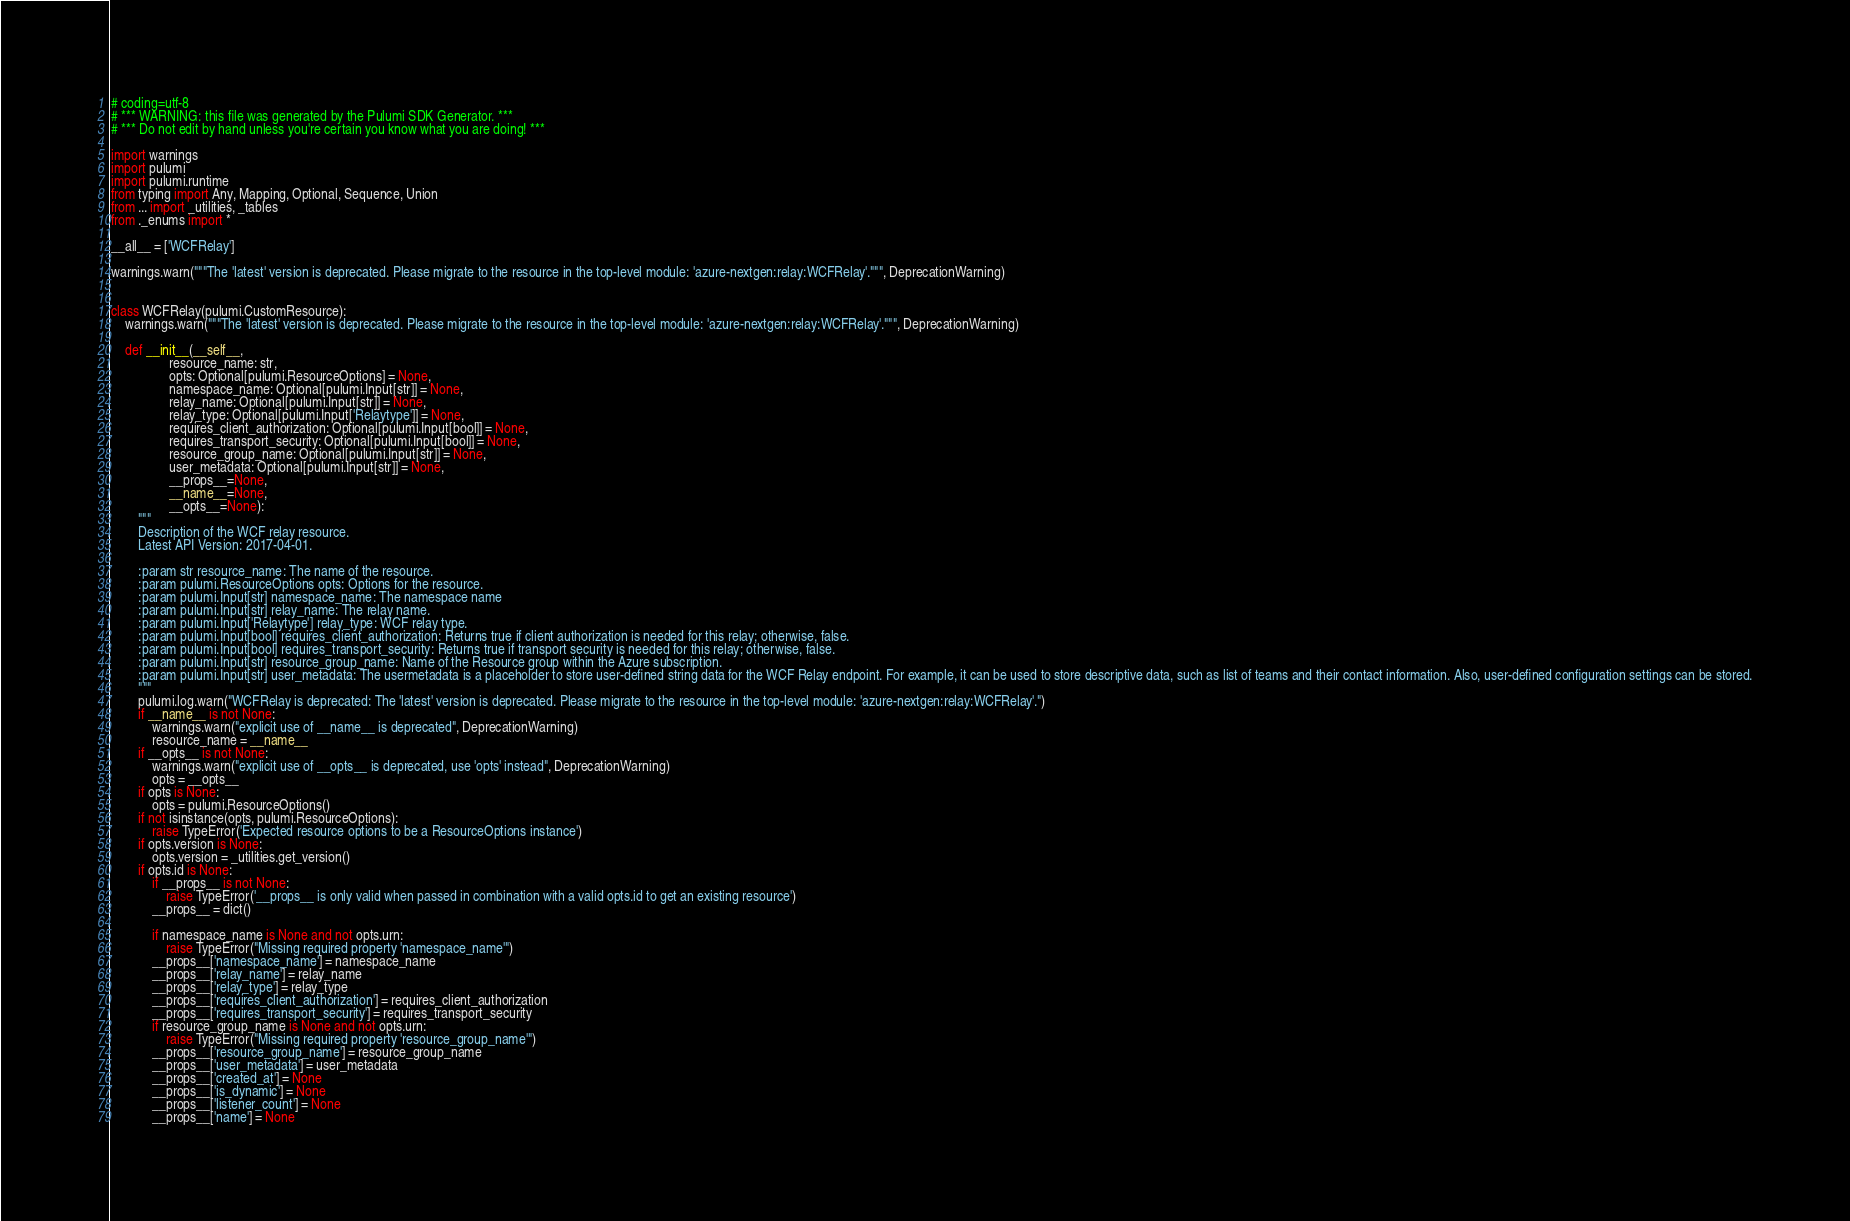Convert code to text. <code><loc_0><loc_0><loc_500><loc_500><_Python_># coding=utf-8
# *** WARNING: this file was generated by the Pulumi SDK Generator. ***
# *** Do not edit by hand unless you're certain you know what you are doing! ***

import warnings
import pulumi
import pulumi.runtime
from typing import Any, Mapping, Optional, Sequence, Union
from ... import _utilities, _tables
from ._enums import *

__all__ = ['WCFRelay']

warnings.warn("""The 'latest' version is deprecated. Please migrate to the resource in the top-level module: 'azure-nextgen:relay:WCFRelay'.""", DeprecationWarning)


class WCFRelay(pulumi.CustomResource):
    warnings.warn("""The 'latest' version is deprecated. Please migrate to the resource in the top-level module: 'azure-nextgen:relay:WCFRelay'.""", DeprecationWarning)

    def __init__(__self__,
                 resource_name: str,
                 opts: Optional[pulumi.ResourceOptions] = None,
                 namespace_name: Optional[pulumi.Input[str]] = None,
                 relay_name: Optional[pulumi.Input[str]] = None,
                 relay_type: Optional[pulumi.Input['Relaytype']] = None,
                 requires_client_authorization: Optional[pulumi.Input[bool]] = None,
                 requires_transport_security: Optional[pulumi.Input[bool]] = None,
                 resource_group_name: Optional[pulumi.Input[str]] = None,
                 user_metadata: Optional[pulumi.Input[str]] = None,
                 __props__=None,
                 __name__=None,
                 __opts__=None):
        """
        Description of the WCF relay resource.
        Latest API Version: 2017-04-01.

        :param str resource_name: The name of the resource.
        :param pulumi.ResourceOptions opts: Options for the resource.
        :param pulumi.Input[str] namespace_name: The namespace name
        :param pulumi.Input[str] relay_name: The relay name.
        :param pulumi.Input['Relaytype'] relay_type: WCF relay type.
        :param pulumi.Input[bool] requires_client_authorization: Returns true if client authorization is needed for this relay; otherwise, false.
        :param pulumi.Input[bool] requires_transport_security: Returns true if transport security is needed for this relay; otherwise, false.
        :param pulumi.Input[str] resource_group_name: Name of the Resource group within the Azure subscription.
        :param pulumi.Input[str] user_metadata: The usermetadata is a placeholder to store user-defined string data for the WCF Relay endpoint. For example, it can be used to store descriptive data, such as list of teams and their contact information. Also, user-defined configuration settings can be stored.
        """
        pulumi.log.warn("WCFRelay is deprecated: The 'latest' version is deprecated. Please migrate to the resource in the top-level module: 'azure-nextgen:relay:WCFRelay'.")
        if __name__ is not None:
            warnings.warn("explicit use of __name__ is deprecated", DeprecationWarning)
            resource_name = __name__
        if __opts__ is not None:
            warnings.warn("explicit use of __opts__ is deprecated, use 'opts' instead", DeprecationWarning)
            opts = __opts__
        if opts is None:
            opts = pulumi.ResourceOptions()
        if not isinstance(opts, pulumi.ResourceOptions):
            raise TypeError('Expected resource options to be a ResourceOptions instance')
        if opts.version is None:
            opts.version = _utilities.get_version()
        if opts.id is None:
            if __props__ is not None:
                raise TypeError('__props__ is only valid when passed in combination with a valid opts.id to get an existing resource')
            __props__ = dict()

            if namespace_name is None and not opts.urn:
                raise TypeError("Missing required property 'namespace_name'")
            __props__['namespace_name'] = namespace_name
            __props__['relay_name'] = relay_name
            __props__['relay_type'] = relay_type
            __props__['requires_client_authorization'] = requires_client_authorization
            __props__['requires_transport_security'] = requires_transport_security
            if resource_group_name is None and not opts.urn:
                raise TypeError("Missing required property 'resource_group_name'")
            __props__['resource_group_name'] = resource_group_name
            __props__['user_metadata'] = user_metadata
            __props__['created_at'] = None
            __props__['is_dynamic'] = None
            __props__['listener_count'] = None
            __props__['name'] = None</code> 